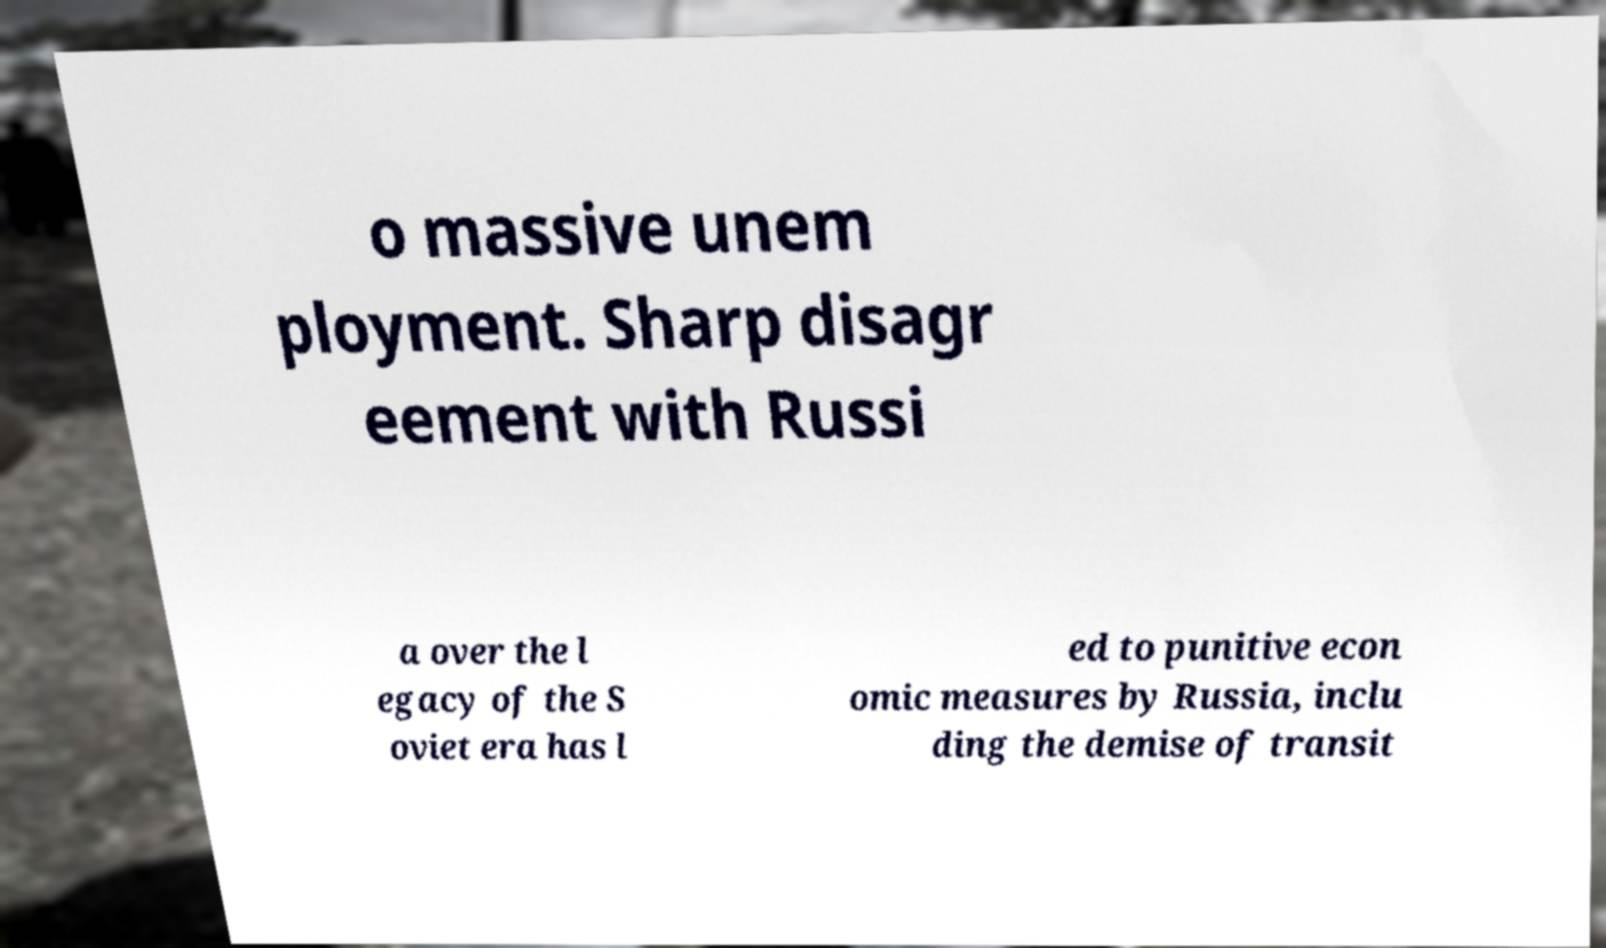Please identify and transcribe the text found in this image. o massive unem ployment. Sharp disagr eement with Russi a over the l egacy of the S oviet era has l ed to punitive econ omic measures by Russia, inclu ding the demise of transit 